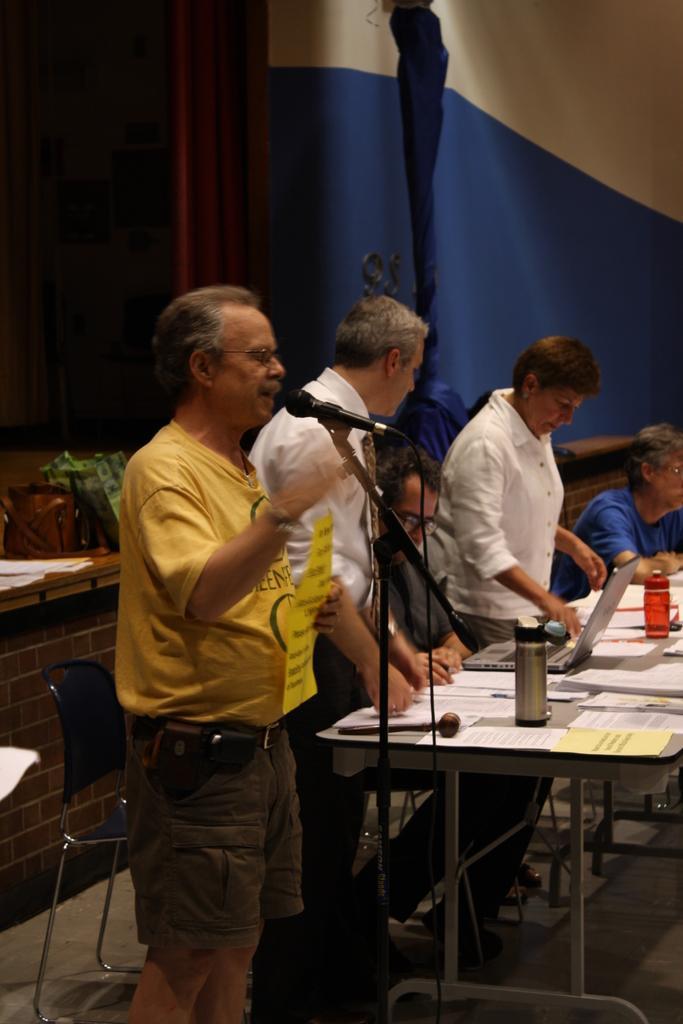In one or two sentences, can you explain what this image depicts? In this image I can see few people were two of them are sitting and rest all are standing. Here I can see a mic and a table. On this table I can see few bottles and number of papers and a laptop. 